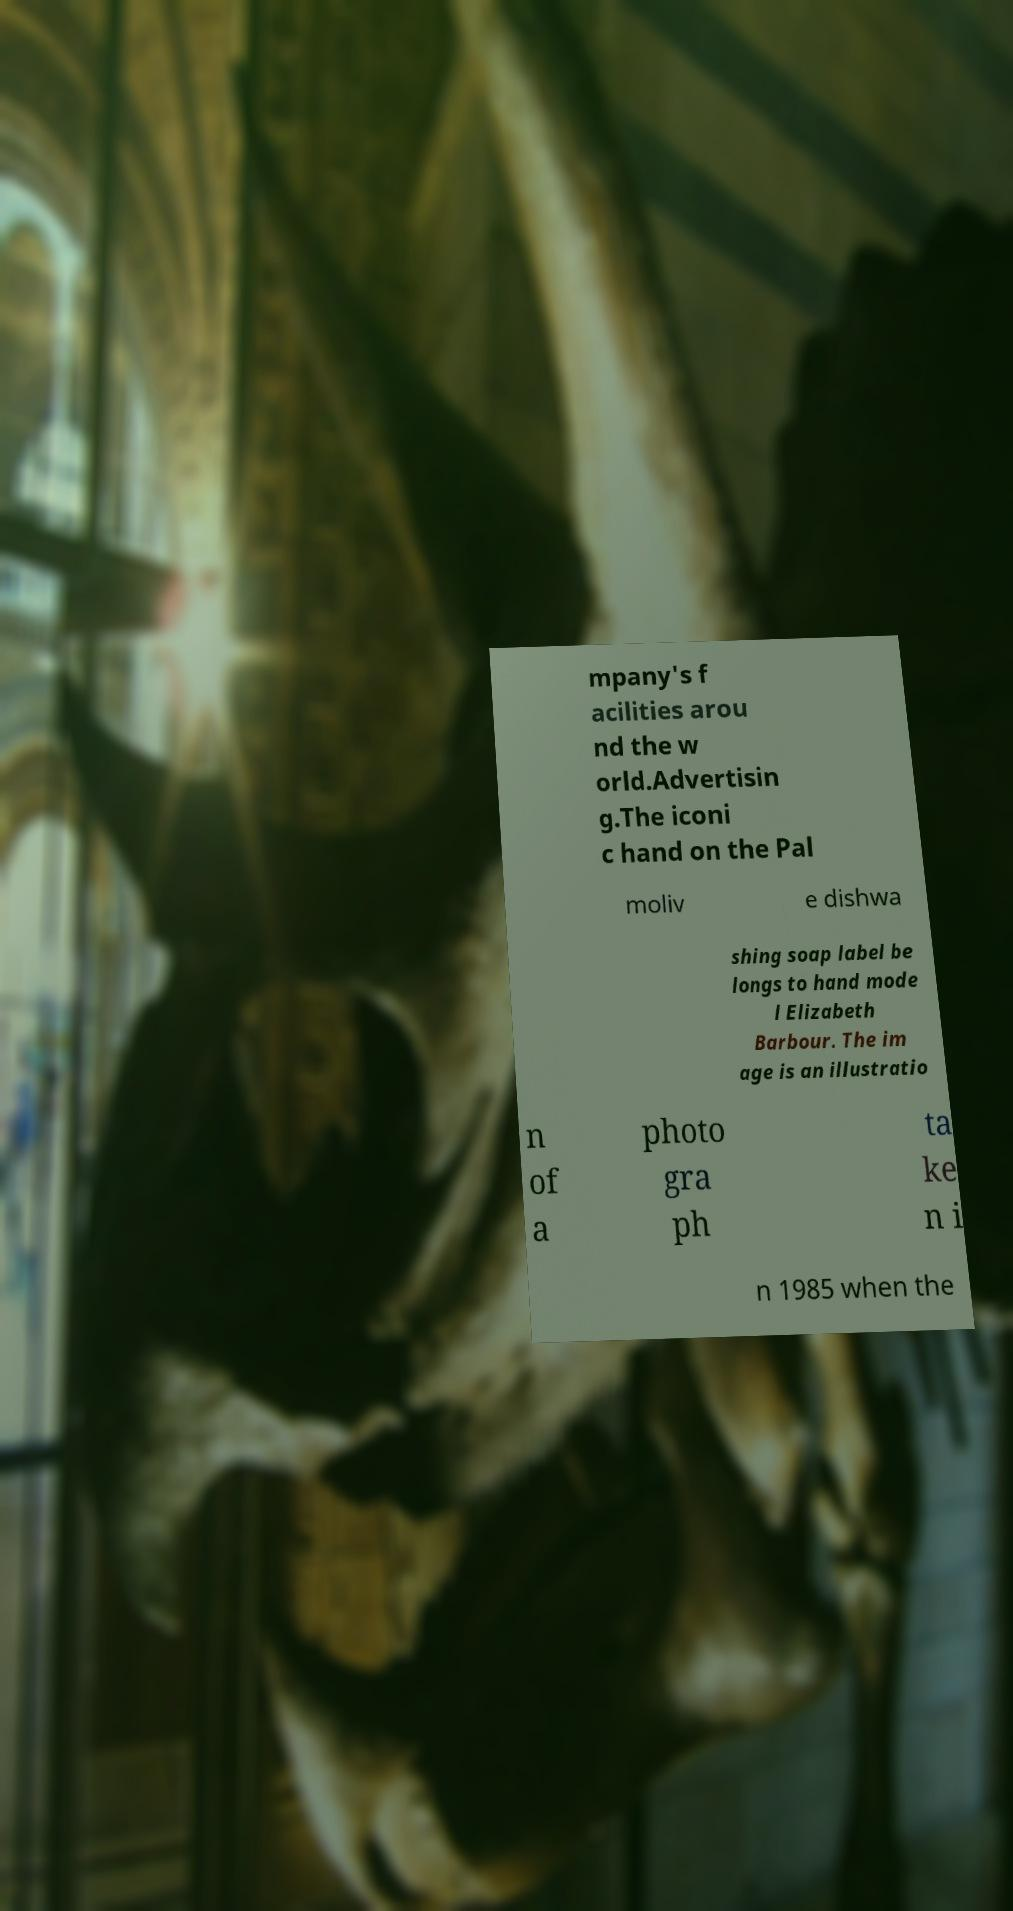I need the written content from this picture converted into text. Can you do that? mpany's f acilities arou nd the w orld.Advertisin g.The iconi c hand on the Pal moliv e dishwa shing soap label be longs to hand mode l Elizabeth Barbour. The im age is an illustratio n of a photo gra ph ta ke n i n 1985 when the 